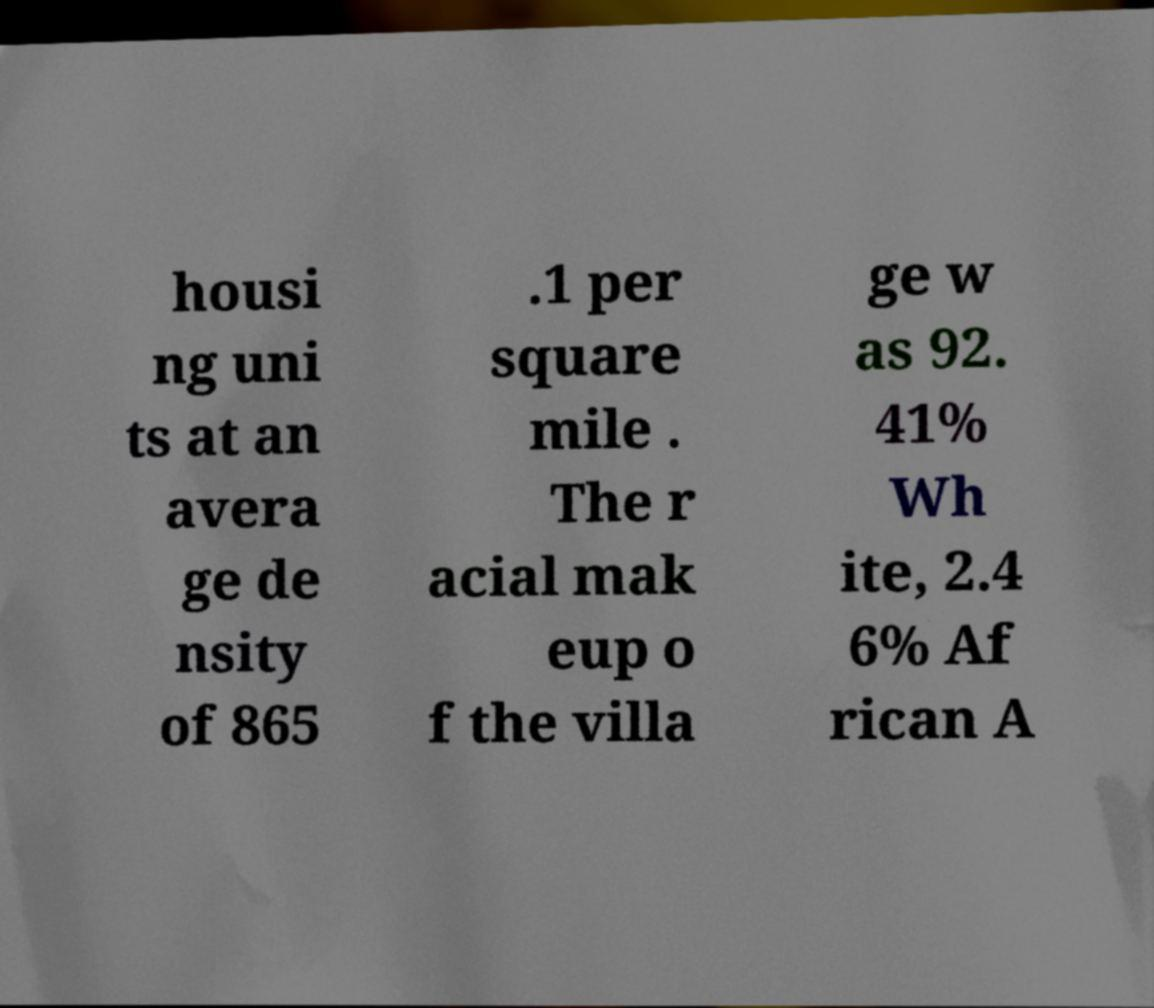Please read and relay the text visible in this image. What does it say? housi ng uni ts at an avera ge de nsity of 865 .1 per square mile . The r acial mak eup o f the villa ge w as 92. 41% Wh ite, 2.4 6% Af rican A 